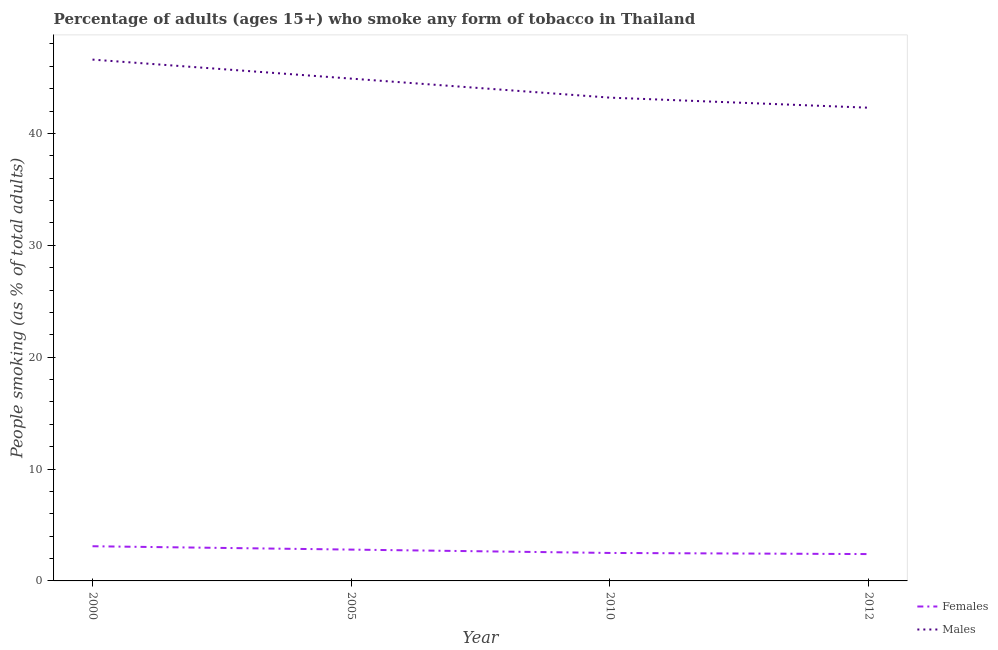Does the line corresponding to percentage of females who smoke intersect with the line corresponding to percentage of males who smoke?
Make the answer very short. No. Is the number of lines equal to the number of legend labels?
Provide a succinct answer. Yes. Across all years, what is the maximum percentage of females who smoke?
Offer a terse response. 3.1. Across all years, what is the minimum percentage of males who smoke?
Make the answer very short. 42.3. In which year was the percentage of males who smoke maximum?
Ensure brevity in your answer.  2000. What is the total percentage of males who smoke in the graph?
Provide a short and direct response. 177. What is the difference between the percentage of females who smoke in 2000 and that in 2005?
Give a very brief answer. 0.3. What is the difference between the percentage of females who smoke in 2005 and the percentage of males who smoke in 2012?
Keep it short and to the point. -39.5. In the year 2005, what is the difference between the percentage of females who smoke and percentage of males who smoke?
Keep it short and to the point. -42.1. In how many years, is the percentage of females who smoke greater than 20 %?
Make the answer very short. 0. What is the ratio of the percentage of males who smoke in 2010 to that in 2012?
Your response must be concise. 1.02. Is the percentage of males who smoke in 2000 less than that in 2010?
Your answer should be compact. No. What is the difference between the highest and the second highest percentage of males who smoke?
Keep it short and to the point. 1.7. What is the difference between the highest and the lowest percentage of females who smoke?
Ensure brevity in your answer.  0.7. In how many years, is the percentage of males who smoke greater than the average percentage of males who smoke taken over all years?
Provide a succinct answer. 2. Is the sum of the percentage of males who smoke in 2005 and 2010 greater than the maximum percentage of females who smoke across all years?
Provide a succinct answer. Yes. Is the percentage of males who smoke strictly greater than the percentage of females who smoke over the years?
Make the answer very short. Yes. What is the difference between two consecutive major ticks on the Y-axis?
Provide a succinct answer. 10. Does the graph contain grids?
Provide a succinct answer. No. Where does the legend appear in the graph?
Provide a succinct answer. Bottom right. What is the title of the graph?
Offer a very short reply. Percentage of adults (ages 15+) who smoke any form of tobacco in Thailand. What is the label or title of the Y-axis?
Your answer should be compact. People smoking (as % of total adults). What is the People smoking (as % of total adults) of Females in 2000?
Keep it short and to the point. 3.1. What is the People smoking (as % of total adults) of Males in 2000?
Provide a succinct answer. 46.6. What is the People smoking (as % of total adults) of Males in 2005?
Offer a terse response. 44.9. What is the People smoking (as % of total adults) of Females in 2010?
Your answer should be compact. 2.5. What is the People smoking (as % of total adults) of Males in 2010?
Keep it short and to the point. 43.2. What is the People smoking (as % of total adults) of Males in 2012?
Keep it short and to the point. 42.3. Across all years, what is the maximum People smoking (as % of total adults) in Females?
Your answer should be compact. 3.1. Across all years, what is the maximum People smoking (as % of total adults) of Males?
Your response must be concise. 46.6. Across all years, what is the minimum People smoking (as % of total adults) of Males?
Give a very brief answer. 42.3. What is the total People smoking (as % of total adults) in Males in the graph?
Your answer should be compact. 177. What is the difference between the People smoking (as % of total adults) in Females in 2000 and that in 2005?
Ensure brevity in your answer.  0.3. What is the difference between the People smoking (as % of total adults) of Males in 2000 and that in 2005?
Your answer should be compact. 1.7. What is the difference between the People smoking (as % of total adults) in Females in 2000 and that in 2010?
Keep it short and to the point. 0.6. What is the difference between the People smoking (as % of total adults) of Males in 2000 and that in 2010?
Keep it short and to the point. 3.4. What is the difference between the People smoking (as % of total adults) of Females in 2000 and that in 2012?
Give a very brief answer. 0.7. What is the difference between the People smoking (as % of total adults) of Females in 2005 and that in 2010?
Provide a short and direct response. 0.3. What is the difference between the People smoking (as % of total adults) of Males in 2005 and that in 2010?
Provide a succinct answer. 1.7. What is the difference between the People smoking (as % of total adults) in Males in 2005 and that in 2012?
Keep it short and to the point. 2.6. What is the difference between the People smoking (as % of total adults) in Females in 2000 and the People smoking (as % of total adults) in Males in 2005?
Provide a succinct answer. -41.8. What is the difference between the People smoking (as % of total adults) of Females in 2000 and the People smoking (as % of total adults) of Males in 2010?
Offer a very short reply. -40.1. What is the difference between the People smoking (as % of total adults) of Females in 2000 and the People smoking (as % of total adults) of Males in 2012?
Ensure brevity in your answer.  -39.2. What is the difference between the People smoking (as % of total adults) in Females in 2005 and the People smoking (as % of total adults) in Males in 2010?
Give a very brief answer. -40.4. What is the difference between the People smoking (as % of total adults) of Females in 2005 and the People smoking (as % of total adults) of Males in 2012?
Ensure brevity in your answer.  -39.5. What is the difference between the People smoking (as % of total adults) of Females in 2010 and the People smoking (as % of total adults) of Males in 2012?
Offer a very short reply. -39.8. What is the average People smoking (as % of total adults) of Females per year?
Offer a very short reply. 2.7. What is the average People smoking (as % of total adults) of Males per year?
Provide a short and direct response. 44.25. In the year 2000, what is the difference between the People smoking (as % of total adults) in Females and People smoking (as % of total adults) in Males?
Offer a terse response. -43.5. In the year 2005, what is the difference between the People smoking (as % of total adults) of Females and People smoking (as % of total adults) of Males?
Your answer should be very brief. -42.1. In the year 2010, what is the difference between the People smoking (as % of total adults) in Females and People smoking (as % of total adults) in Males?
Your answer should be compact. -40.7. In the year 2012, what is the difference between the People smoking (as % of total adults) in Females and People smoking (as % of total adults) in Males?
Offer a terse response. -39.9. What is the ratio of the People smoking (as % of total adults) in Females in 2000 to that in 2005?
Your answer should be compact. 1.11. What is the ratio of the People smoking (as % of total adults) in Males in 2000 to that in 2005?
Ensure brevity in your answer.  1.04. What is the ratio of the People smoking (as % of total adults) in Females in 2000 to that in 2010?
Make the answer very short. 1.24. What is the ratio of the People smoking (as % of total adults) of Males in 2000 to that in 2010?
Provide a succinct answer. 1.08. What is the ratio of the People smoking (as % of total adults) of Females in 2000 to that in 2012?
Your answer should be compact. 1.29. What is the ratio of the People smoking (as % of total adults) in Males in 2000 to that in 2012?
Provide a succinct answer. 1.1. What is the ratio of the People smoking (as % of total adults) in Females in 2005 to that in 2010?
Provide a short and direct response. 1.12. What is the ratio of the People smoking (as % of total adults) of Males in 2005 to that in 2010?
Provide a succinct answer. 1.04. What is the ratio of the People smoking (as % of total adults) of Females in 2005 to that in 2012?
Make the answer very short. 1.17. What is the ratio of the People smoking (as % of total adults) of Males in 2005 to that in 2012?
Your answer should be very brief. 1.06. What is the ratio of the People smoking (as % of total adults) in Females in 2010 to that in 2012?
Offer a terse response. 1.04. What is the ratio of the People smoking (as % of total adults) in Males in 2010 to that in 2012?
Keep it short and to the point. 1.02. What is the difference between the highest and the second highest People smoking (as % of total adults) of Females?
Give a very brief answer. 0.3. What is the difference between the highest and the second highest People smoking (as % of total adults) of Males?
Give a very brief answer. 1.7. What is the difference between the highest and the lowest People smoking (as % of total adults) of Males?
Your response must be concise. 4.3. 